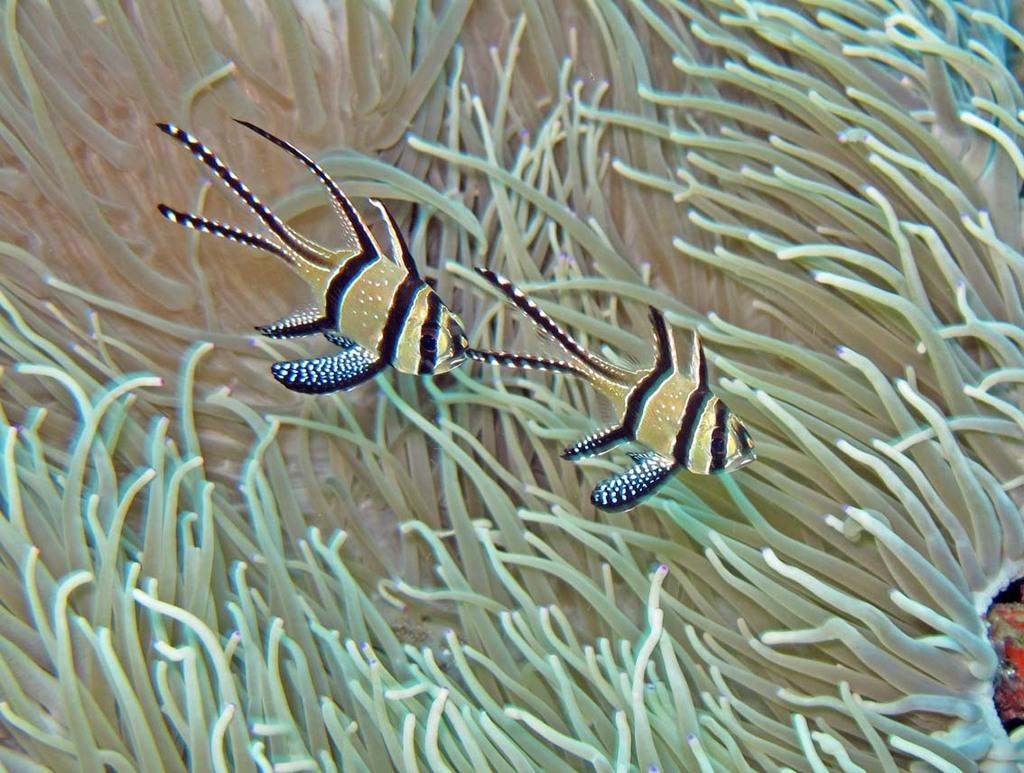What type of animals can be seen in the image? There are fishes in the image. What colors are the fishes in the image? The fishes are in black, brown, and white colors. What other living organisms can be seen in the image? There are plants in the image. What color are the plants in the image? The plants are green in color. Where is the alarm located in the image? There is no alarm present in the image. Can you describe the nest in the image? There is no nest present in the image. 